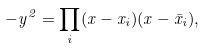<formula> <loc_0><loc_0><loc_500><loc_500>- y ^ { 2 } = \prod _ { i } ( x - x _ { i } ) ( x - \bar { x } _ { i } ) ,</formula> 